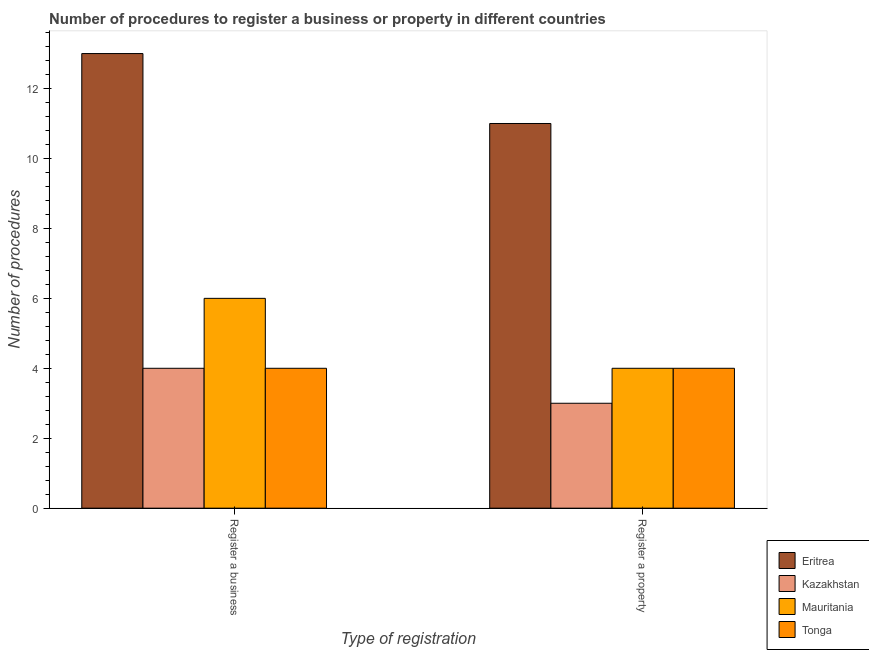How many different coloured bars are there?
Make the answer very short. 4. Are the number of bars on each tick of the X-axis equal?
Offer a very short reply. Yes. How many bars are there on the 1st tick from the left?
Your answer should be very brief. 4. What is the label of the 2nd group of bars from the left?
Provide a succinct answer. Register a property. What is the number of procedures to register a property in Eritrea?
Give a very brief answer. 11. Across all countries, what is the maximum number of procedures to register a business?
Make the answer very short. 13. Across all countries, what is the minimum number of procedures to register a business?
Keep it short and to the point. 4. In which country was the number of procedures to register a property maximum?
Your response must be concise. Eritrea. In which country was the number of procedures to register a property minimum?
Offer a terse response. Kazakhstan. What is the total number of procedures to register a business in the graph?
Provide a short and direct response. 27. What is the difference between the number of procedures to register a business in Tonga and that in Mauritania?
Ensure brevity in your answer.  -2. What is the difference between the number of procedures to register a business in Tonga and the number of procedures to register a property in Mauritania?
Provide a short and direct response. 0. What is the average number of procedures to register a business per country?
Offer a terse response. 6.75. What is the difference between the number of procedures to register a property and number of procedures to register a business in Tonga?
Give a very brief answer. 0. In how many countries, is the number of procedures to register a business greater than 6.8 ?
Ensure brevity in your answer.  1. What is the ratio of the number of procedures to register a business in Mauritania to that in Tonga?
Provide a succinct answer. 1.5. In how many countries, is the number of procedures to register a property greater than the average number of procedures to register a property taken over all countries?
Make the answer very short. 1. What does the 2nd bar from the left in Register a property represents?
Keep it short and to the point. Kazakhstan. What does the 3rd bar from the right in Register a property represents?
Your answer should be compact. Kazakhstan. How many bars are there?
Ensure brevity in your answer.  8. How many countries are there in the graph?
Provide a short and direct response. 4. What is the difference between two consecutive major ticks on the Y-axis?
Keep it short and to the point. 2. Does the graph contain any zero values?
Keep it short and to the point. No. Does the graph contain grids?
Provide a succinct answer. No. Where does the legend appear in the graph?
Your answer should be compact. Bottom right. How many legend labels are there?
Provide a succinct answer. 4. What is the title of the graph?
Your answer should be very brief. Number of procedures to register a business or property in different countries. Does "Russian Federation" appear as one of the legend labels in the graph?
Provide a short and direct response. No. What is the label or title of the X-axis?
Offer a very short reply. Type of registration. What is the label or title of the Y-axis?
Offer a terse response. Number of procedures. What is the Number of procedures in Eritrea in Register a business?
Give a very brief answer. 13. What is the Number of procedures in Tonga in Register a business?
Ensure brevity in your answer.  4. What is the Number of procedures of Tonga in Register a property?
Offer a terse response. 4. Across all Type of registration, what is the maximum Number of procedures of Kazakhstan?
Offer a terse response. 4. Across all Type of registration, what is the maximum Number of procedures in Mauritania?
Offer a very short reply. 6. Across all Type of registration, what is the maximum Number of procedures of Tonga?
Make the answer very short. 4. What is the total Number of procedures of Kazakhstan in the graph?
Give a very brief answer. 7. What is the difference between the Number of procedures in Eritrea in Register a business and that in Register a property?
Provide a succinct answer. 2. What is the difference between the Number of procedures in Mauritania in Register a business and that in Register a property?
Your response must be concise. 2. What is the difference between the Number of procedures in Eritrea in Register a business and the Number of procedures in Kazakhstan in Register a property?
Your answer should be very brief. 10. What is the difference between the Number of procedures of Eritrea in Register a business and the Number of procedures of Mauritania in Register a property?
Offer a terse response. 9. What is the difference between the Number of procedures of Kazakhstan in Register a business and the Number of procedures of Mauritania in Register a property?
Provide a short and direct response. 0. What is the difference between the Number of procedures in Mauritania in Register a business and the Number of procedures in Tonga in Register a property?
Provide a succinct answer. 2. What is the difference between the Number of procedures in Eritrea and Number of procedures in Kazakhstan in Register a business?
Provide a short and direct response. 9. What is the difference between the Number of procedures in Eritrea and Number of procedures in Tonga in Register a business?
Offer a terse response. 9. What is the difference between the Number of procedures in Kazakhstan and Number of procedures in Mauritania in Register a business?
Make the answer very short. -2. What is the difference between the Number of procedures of Kazakhstan and Number of procedures of Tonga in Register a business?
Keep it short and to the point. 0. What is the difference between the Number of procedures of Eritrea and Number of procedures of Kazakhstan in Register a property?
Your answer should be compact. 8. What is the difference between the Number of procedures in Eritrea and Number of procedures in Mauritania in Register a property?
Your answer should be very brief. 7. What is the difference between the Number of procedures of Kazakhstan and Number of procedures of Tonga in Register a property?
Your answer should be very brief. -1. What is the difference between the Number of procedures of Mauritania and Number of procedures of Tonga in Register a property?
Your answer should be compact. 0. What is the ratio of the Number of procedures of Eritrea in Register a business to that in Register a property?
Make the answer very short. 1.18. What is the ratio of the Number of procedures of Kazakhstan in Register a business to that in Register a property?
Offer a very short reply. 1.33. What is the ratio of the Number of procedures in Tonga in Register a business to that in Register a property?
Provide a succinct answer. 1. What is the difference between the highest and the second highest Number of procedures of Kazakhstan?
Ensure brevity in your answer.  1. What is the difference between the highest and the second highest Number of procedures in Tonga?
Offer a terse response. 0. What is the difference between the highest and the lowest Number of procedures of Kazakhstan?
Make the answer very short. 1. What is the difference between the highest and the lowest Number of procedures in Mauritania?
Your answer should be compact. 2. 